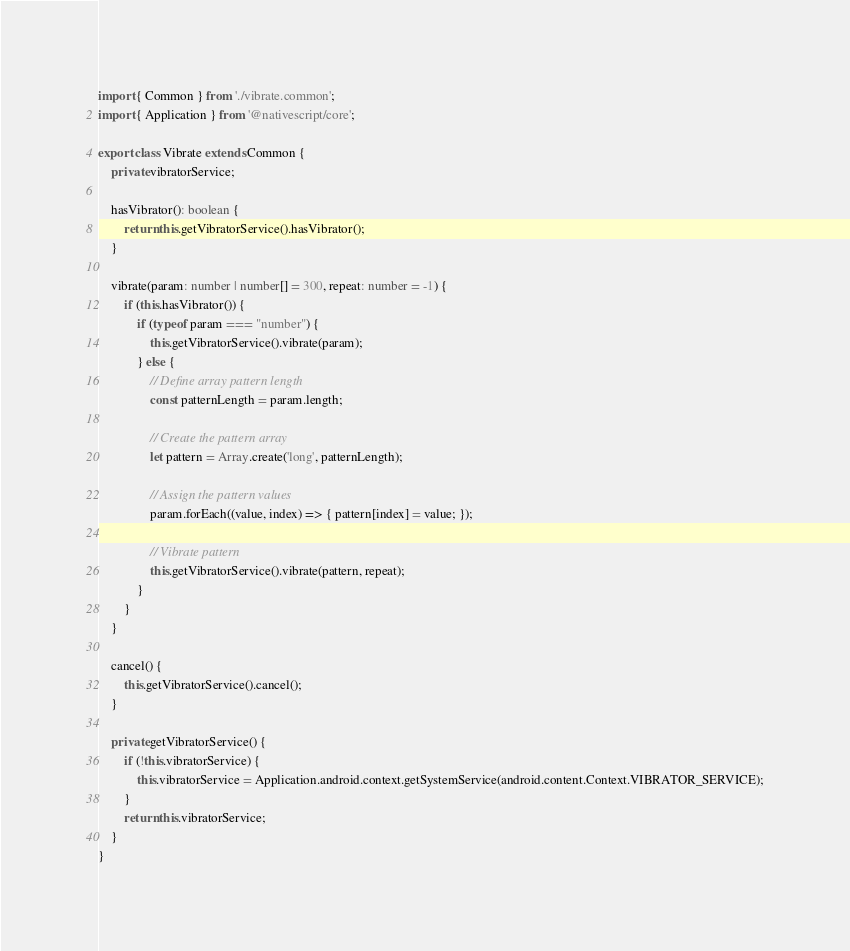Convert code to text. <code><loc_0><loc_0><loc_500><loc_500><_TypeScript_>import { Common } from './vibrate.common';
import { Application } from '@nativescript/core';

export class Vibrate extends Common {
    private vibratorService;

    hasVibrator(): boolean {
        return this.getVibratorService().hasVibrator();
    }

    vibrate(param: number | number[] = 300, repeat: number = -1) {
        if (this.hasVibrator()) {
            if (typeof param === "number") {
                this.getVibratorService().vibrate(param);
            } else {
                // Define array pattern length
                const patternLength = param.length;

                // Create the pattern array
                let pattern = Array.create('long', patternLength);

                // Assign the pattern values
                param.forEach((value, index) => { pattern[index] = value; });

                // Vibrate pattern
                this.getVibratorService().vibrate(pattern, repeat);
            }
        }
    }

    cancel() {
        this.getVibratorService().cancel();
    }

    private getVibratorService() {
        if (!this.vibratorService) {
            this.vibratorService = Application.android.context.getSystemService(android.content.Context.VIBRATOR_SERVICE);
        }
        return this.vibratorService;
    }
}
</code> 